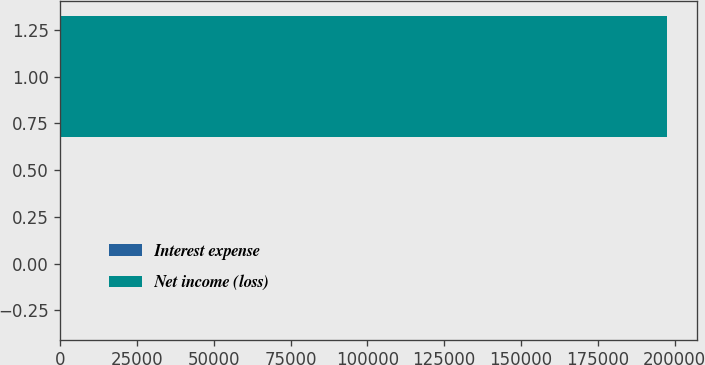Convert chart. <chart><loc_0><loc_0><loc_500><loc_500><bar_chart><fcel>Interest expense<fcel>Net income (loss)<nl><fcel>373<fcel>197494<nl></chart> 